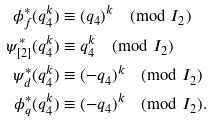<formula> <loc_0><loc_0><loc_500><loc_500>\phi _ { f } ^ { * } ( q _ { 4 } ^ { k } ) & \equiv ( q _ { 4 } ) ^ { k } \pmod { I _ { 2 } } \\ \psi _ { [ 2 ] } ^ { * } ( q _ { 4 } ^ { k } ) & \equiv q _ { 4 } ^ { k } \pmod { I _ { 2 } } \\ \psi _ { d } ^ { * } ( q _ { 4 } ^ { k } ) & \equiv ( - q _ { 4 } ) ^ { k } \pmod { I _ { 2 } } \\ \phi _ { q } ^ { * } ( q _ { 4 } ^ { k } ) & \equiv ( - q _ { 4 } ) ^ { k } \pmod { I _ { 2 } } .</formula> 